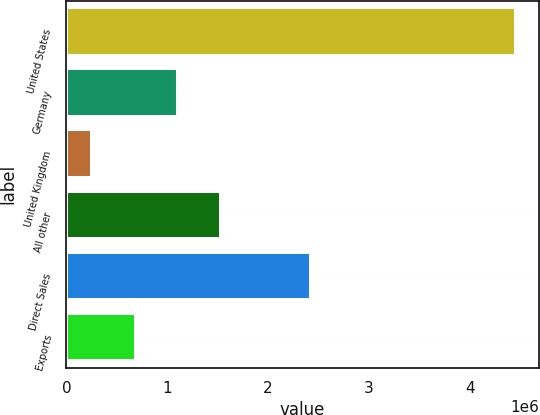Convert chart to OTSL. <chart><loc_0><loc_0><loc_500><loc_500><bar_chart><fcel>United States<fcel>Germany<fcel>United Kingdom<fcel>All other<fcel>Direct Sales<fcel>Exports<nl><fcel>4.46139e+06<fcel>1.10708e+06<fcel>250627<fcel>1.52815e+06<fcel>2.42791e+06<fcel>686000<nl></chart> 